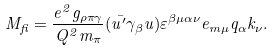Convert formula to latex. <formula><loc_0><loc_0><loc_500><loc_500>M _ { f i } = \frac { e ^ { 2 } g _ { \rho \pi \gamma } } { Q ^ { 2 } m _ { \pi } } ( \bar { u ^ { \prime } } \gamma _ { \beta } u ) \varepsilon ^ { \beta \mu \alpha \nu } e _ { m \mu } q _ { \alpha } k _ { \nu } .</formula> 